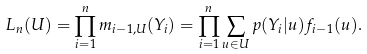<formula> <loc_0><loc_0><loc_500><loc_500>L _ { n } ( U ) = \prod _ { i = 1 } ^ { n } m _ { i - 1 , U } ( Y _ { i } ) = \prod _ { i = 1 } ^ { n } \sum _ { u \in U } p ( Y _ { i } | u ) f _ { i - 1 } ( u ) .</formula> 